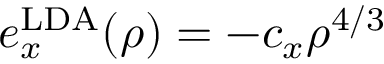Convert formula to latex. <formula><loc_0><loc_0><loc_500><loc_500>e _ { x } ^ { L D A } ( \rho ) = - c _ { x } \rho ^ { 4 / 3 }</formula> 